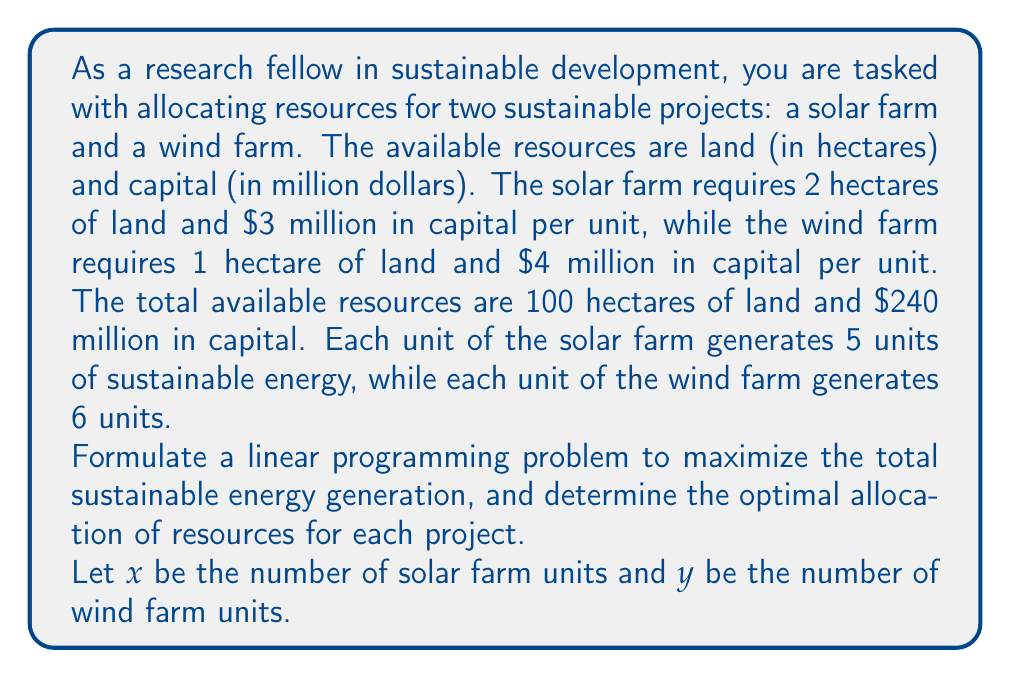Give your solution to this math problem. To solve this linear programming problem, we'll follow these steps:

1. Formulate the objective function:
   Maximize $Z = 5x + 6y$ (total sustainable energy generation)

2. Identify the constraints:
   Land constraint: $2x + y \leq 100$
   Capital constraint: $3x + 4y \leq 240$
   Non-negativity constraints: $x \geq 0, y \geq 0$

3. Graph the feasible region:
   We'll plot the constraints on a coordinate system:

[asy]
size(200,200);
import graph;

// Draw axes
axes("x", "y", (0,0), (60,60), Arrow);

// Plot constraints
draw((0,100)--(50,0), blue+1);
draw((0,60)--(80,0), red+1);

// Shade feasible region
fill((0,0)--(0,60)--(40,40)--(50,0)--cycle, palegreen);

// Label constraints
label("$2x + y = 100$", (25,50), N, blue);
label("$3x + 4y = 240$", (40,30), SE, red);
label("Feasible Region", (20,20), green);

// Label axes
label("Solar Farm Units (x)", (55,0), S);
label("Wind Farm Units (y)", (0,55), W);
[/asy]

4. Identify the corner points of the feasible region:
   A (0, 0)
   B (0, 60)
   C (intersection of constraints)
   D (50, 0)

   To find point C, solve the system of equations:
   $$\begin{cases}
   2x + y = 100 \\
   3x + 4y = 240
   \end{cases}$$

   Multiply the first equation by 2 and subtract from the second:
   $$\begin{aligned}
   4x + 2y &= 200 \\
   3x + 4y &= 240 \\
   x - 2y &= -40 \\
   x &= 2y - 40
   \end{aligned}$$

   Substitute back into $2x + y = 100$:
   $$\begin{aligned}
   2(2y - 40) + y &= 100 \\
   4y - 80 + y &= 100 \\
   5y &= 180 \\
   y &= 36
   \end{aligned}$$

   Then $x = 2(36) - 40 = 32$

   So, point C is (32, 36)

5. Evaluate the objective function at each corner point:
   A (0, 0): $Z = 5(0) + 6(0) = 0$
   B (0, 60): $Z = 5(0) + 6(60) = 360$
   C (32, 36): $Z = 5(32) + 6(36) = 376$
   D (50, 0): $Z = 5(50) + 6(0) = 250$

The maximum value of Z occurs at point C (32, 36).
Answer: The optimal allocation of resources is 32 units for the solar farm and 36 units for the wind farm, generating a total of 376 units of sustainable energy. 